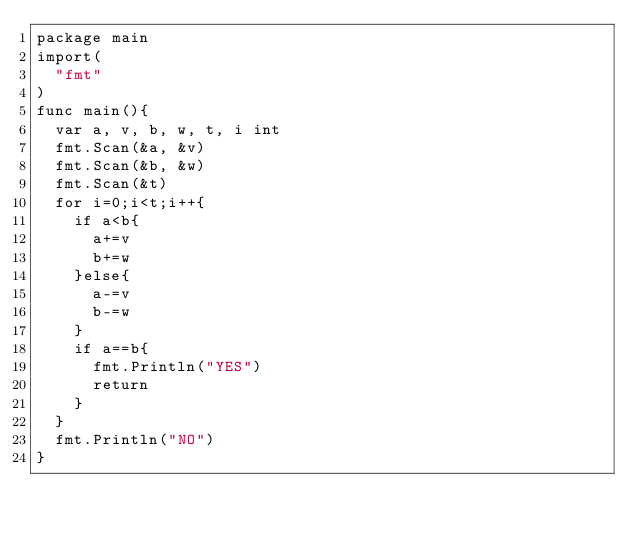<code> <loc_0><loc_0><loc_500><loc_500><_Go_>package main
import(
  "fmt"
)
func main(){
  var a, v, b, w, t, i int
  fmt.Scan(&a, &v)
  fmt.Scan(&b, &w)
  fmt.Scan(&t)
  for i=0;i<t;i++{
    if a<b{
      a+=v
      b+=w
    }else{
      a-=v
      b-=w
    }
    if a==b{
      fmt.Println("YES")
      return
    }
  }
  fmt.Println("NO")
}
</code> 